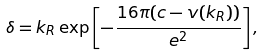<formula> <loc_0><loc_0><loc_500><loc_500>\delta = k _ { R } \exp \left [ - \frac { 1 6 \pi ( c - v ( k _ { R } ) ) } { e ^ { 2 } } \right ] ,</formula> 